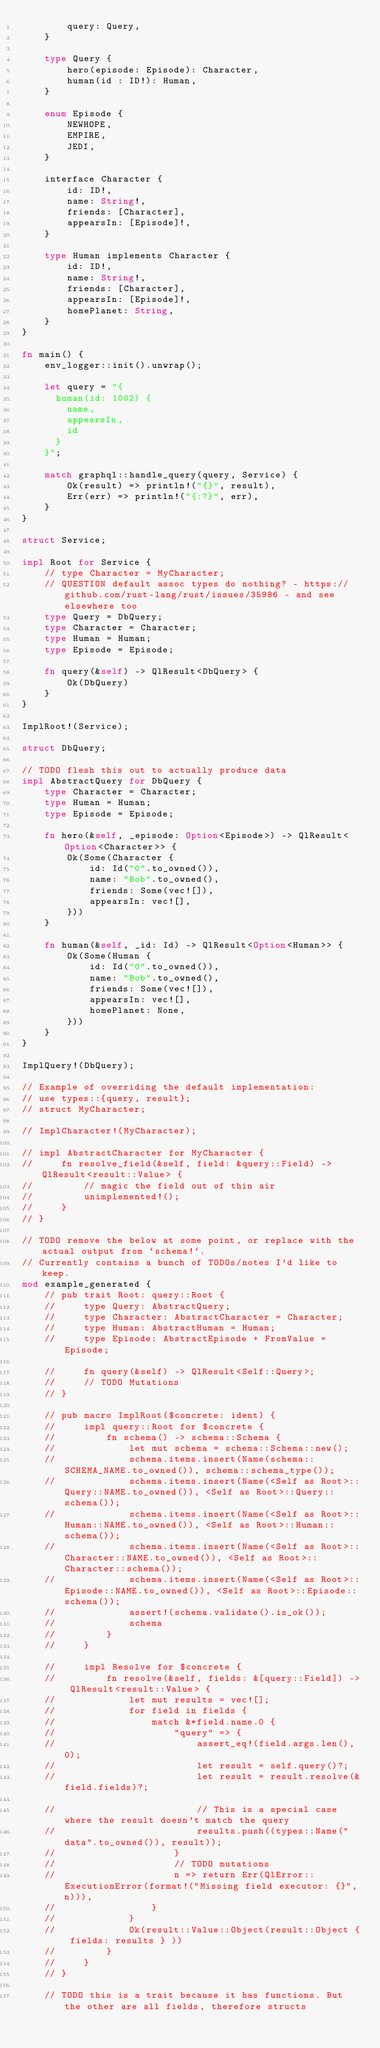<code> <loc_0><loc_0><loc_500><loc_500><_Rust_>        query: Query,
    }

    type Query {
        hero(episode: Episode): Character,
        human(id : ID!): Human,
    }

    enum Episode {
        NEWHOPE,
        EMPIRE,
        JEDI,
    }

    interface Character {
        id: ID!,
        name: String!,
        friends: [Character],
        appearsIn: [Episode]!,
    }

    type Human implements Character {
        id: ID!,
        name: String!,
        friends: [Character],
        appearsIn: [Episode]!,
        homePlanet: String,
    }
}

fn main() {
    env_logger::init().unwrap();

    let query = "{
      human(id: 1002) {
        name,
        appearsIn,
        id
      }
    }";

    match graphql::handle_query(query, Service) {
        Ok(result) => println!("{}", result),
        Err(err) => println!("{:?}", err),
    }
}

struct Service;

impl Root for Service {
    // type Character = MyCharacter;
    // QUESTION default assoc types do nothing? - https://github.com/rust-lang/rust/issues/35986 - and see elsewhere too
    type Query = DbQuery;
    type Character = Character;
    type Human = Human;
    type Episode = Episode;

    fn query(&self) -> QlResult<DbQuery> {
        Ok(DbQuery)
    }
}

ImplRoot!(Service);

struct DbQuery;

// TODO flesh this out to actually produce data
impl AbstractQuery for DbQuery {
    type Character = Character;
    type Human = Human;
    type Episode = Episode;

    fn hero(&self, _episode: Option<Episode>) -> QlResult<Option<Character>> {
        Ok(Some(Character {
            id: Id("0".to_owned()),
            name: "Bob".to_owned(),
            friends: Some(vec![]),
            appearsIn: vec![],
        }))
    }

    fn human(&self, _id: Id) -> QlResult<Option<Human>> {
        Ok(Some(Human {
            id: Id("0".to_owned()),
            name: "Bob".to_owned(),
            friends: Some(vec![]),
            appearsIn: vec![],
            homePlanet: None,
        }))
    }
}

ImplQuery!(DbQuery);

// Example of overriding the default implementation:
// use types::{query, result};
// struct MyCharacter;

// ImplCharacter!(MyCharacter);

// impl AbstractCharacter for MyCharacter {
//     fn resolve_field(&self, field: &query::Field) -> QlResult<result::Value> {
//         // magic the field out of thin air
//         unimplemented!();
//     }
// }

// TODO remove the below at some point, or replace with the actual output from `schema!`.
// Currently contains a bunch of TODOs/notes I'd like to keep.
mod example_generated {
    // pub trait Root: query::Root {
    //     type Query: AbstractQuery;
    //     type Character: AbstractCharacter = Character;
    //     type Human: AbstractHuman = Human;
    //     type Episode: AbstractEpisode + FromValue = Episode;

    //     fn query(&self) -> QlResult<Self::Query>;
    //     // TODO Mutations
    // }

    // pub macro ImplRoot($concrete: ident) {
    //     impl query::Root for $concrete {
    //         fn schema() -> schema::Schema {
    //             let mut schema = schema::Schema::new();
    //             schema.items.insert(Name(schema::SCHEMA_NAME.to_owned()), schema::schema_type());
    //             schema.items.insert(Name(<Self as Root>::Query::NAME.to_owned()), <Self as Root>::Query::schema());
    //             schema.items.insert(Name(<Self as Root>::Human::NAME.to_owned()), <Self as Root>::Human::schema());
    //             schema.items.insert(Name(<Self as Root>::Character::NAME.to_owned()), <Self as Root>::Character::schema());
    //             schema.items.insert(Name(<Self as Root>::Episode::NAME.to_owned()), <Self as Root>::Episode::schema());
    //             assert!(schema.validate().is_ok());
    //             schema
    //         }
    //     }

    //     impl Resolve for $concrete {
    //         fn resolve(&self, fields: &[query::Field]) -> QlResult<result::Value> {
    //             let mut results = vec![];
    //             for field in fields {
    //                 match &*field.name.0 {
    //                     "query" => {
    //                         assert_eq!(field.args.len(), 0);
    //                         let result = self.query()?;
    //                         let result = result.resolve(&field.fields)?;

    //                         // This is a special case where the result doesn't match the query
    //                         results.push((types::Name("data".to_owned()), result));
    //                     }
    //                     // TODO mutations
    //                     n => return Err(QlError::ExecutionError(format!("Missing field executor: {}", n))),
    //                 }
    //             }
    //             Ok(result::Value::Object(result::Object { fields: results } ))
    //         }
    //     }
    // }

    // TODO this is a trait because it has functions. But the other are all fields, therefore structs</code> 